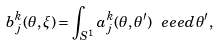<formula> <loc_0><loc_0><loc_500><loc_500>b _ { j } ^ { k } ( \theta , \xi ) = \int _ { S ^ { 1 } } a _ { j } ^ { k } ( \theta , \theta ^ { \prime } ) \ e e e d \theta ^ { \prime } ,</formula> 